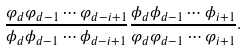Convert formula to latex. <formula><loc_0><loc_0><loc_500><loc_500>\frac { \varphi _ { d } \varphi _ { d - 1 } \cdots \varphi _ { d - i + 1 } } { \phi _ { d } \phi _ { d - 1 } \cdots \phi _ { d - i + 1 } } \frac { \phi _ { d } \phi _ { d - 1 } \cdots \phi _ { i + 1 } } { \varphi _ { d } \varphi _ { d - 1 } \cdots \varphi _ { i + 1 } } .</formula> 